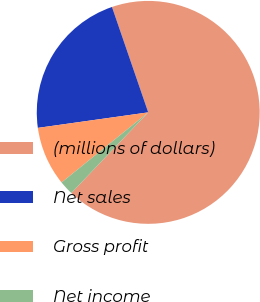Convert chart. <chart><loc_0><loc_0><loc_500><loc_500><pie_chart><fcel>(millions of dollars)<fcel>Net sales<fcel>Gross profit<fcel>Net income<nl><fcel>67.39%<fcel>21.95%<fcel>8.6%<fcel>2.06%<nl></chart> 